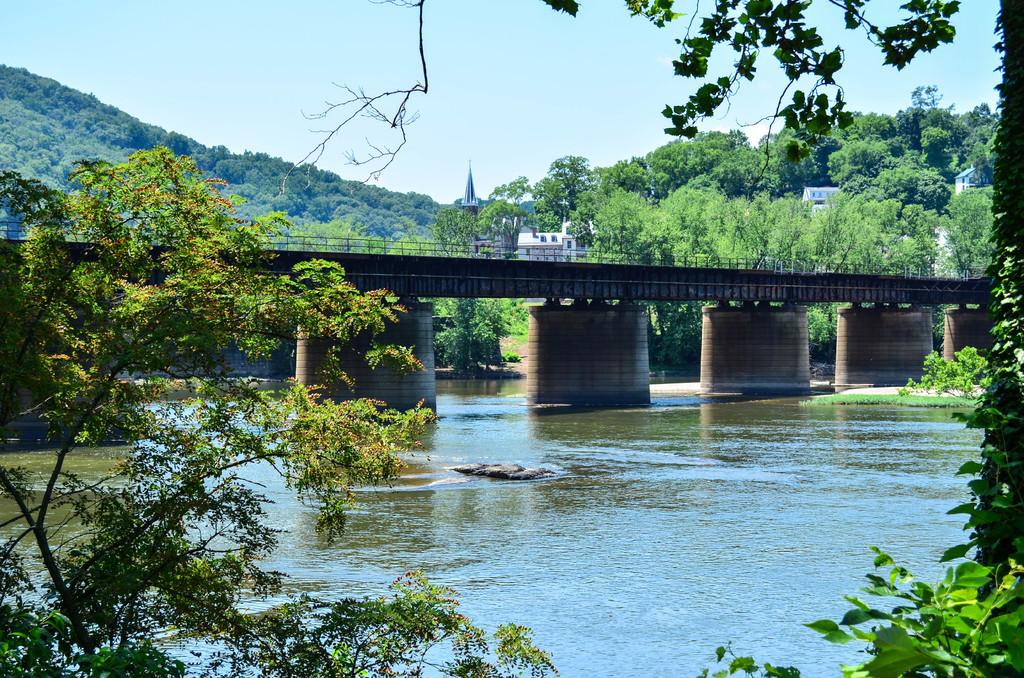What structure is present in the image? There is a bridge in the image. Where is the bridge located? The bridge is placed in water. What can be seen on the right side of the image? There are trees and buildings on the right side of the image. What is visible in the background of the image? There is a group of trees and the sky in the background of the image. What type of fruit is hanging from the bridge in the image? There is no fruit hanging from the bridge in the image. What game are the people playing on the bridge? There are no people or games present on the bridge in the image. 